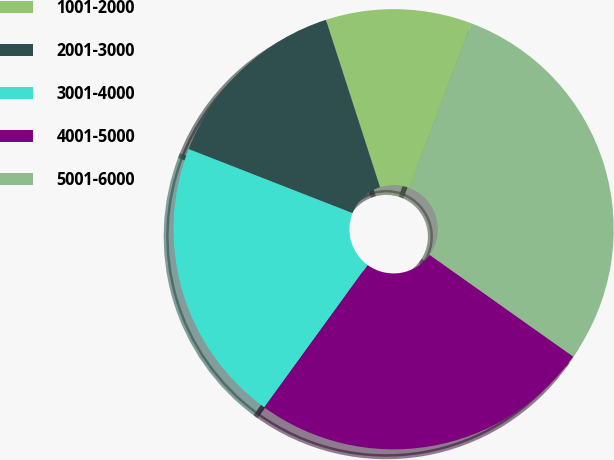Convert chart. <chart><loc_0><loc_0><loc_500><loc_500><pie_chart><fcel>1001-2000<fcel>2001-3000<fcel>3001-4000<fcel>4001-5000<fcel>5001-6000<nl><fcel>10.73%<fcel>14.09%<fcel>20.94%<fcel>25.18%<fcel>29.06%<nl></chart> 